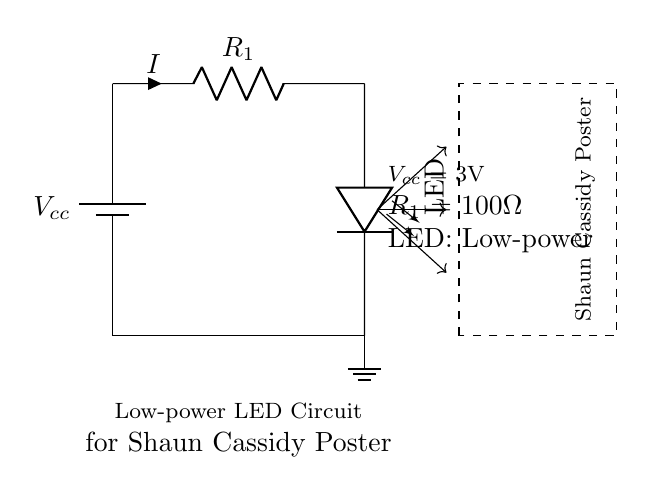What is the voltage of this circuit? The voltage is 3V, which is indicated as Vcc from the battery source in the circuit diagram.
Answer: 3V What is the resistance value used in this circuit? The resistance value is 100 Ohms, which is labeled as R1 in the circuit diagram.
Answer: 100 Ohm What component is used to illuminate the poster? The component used is an LED, shown in the circuit diagram that connects to the resistor and illuminates the poster.
Answer: LED How many light rays are depicted in the circuit? There are three light rays illustrated as arrows pointing from the LED towards the vintage Shaun Cassidy poster.
Answer: Three What type of circuit is shown in the diagram? The circuit is a low-power LED circuit designed specifically for illumination, as stated in the label beneath the circuit.
Answer: Low-power LED circuit How does the current flow in this circuit? The current flows from the battery, through the resistor R1, and then through the LED to ground, completing the circuit.
Answer: From battery to LED to ground 